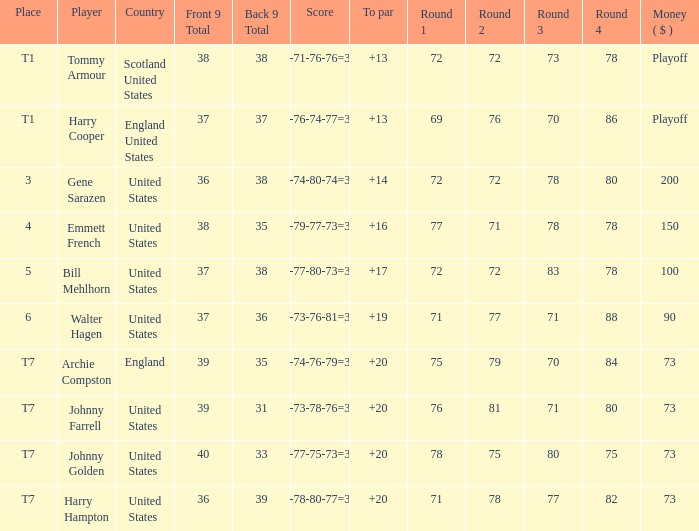Which country has a to par less than 19 and a score of 75-79-77-73=304? United States. 